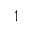<formula> <loc_0><loc_0><loc_500><loc_500>_ { 1 }</formula> 